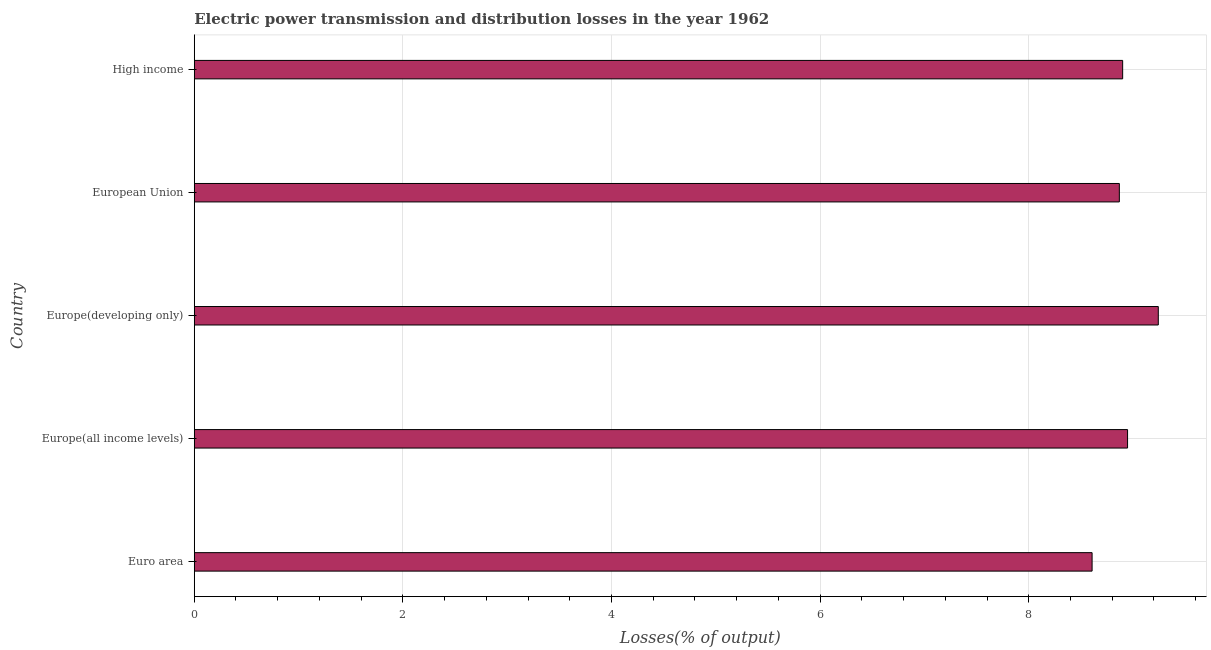Does the graph contain any zero values?
Keep it short and to the point. No. What is the title of the graph?
Offer a very short reply. Electric power transmission and distribution losses in the year 1962. What is the label or title of the X-axis?
Your answer should be very brief. Losses(% of output). What is the electric power transmission and distribution losses in High income?
Provide a succinct answer. 8.9. Across all countries, what is the maximum electric power transmission and distribution losses?
Your response must be concise. 9.24. Across all countries, what is the minimum electric power transmission and distribution losses?
Give a very brief answer. 8.61. In which country was the electric power transmission and distribution losses maximum?
Your response must be concise. Europe(developing only). In which country was the electric power transmission and distribution losses minimum?
Give a very brief answer. Euro area. What is the sum of the electric power transmission and distribution losses?
Give a very brief answer. 44.56. What is the difference between the electric power transmission and distribution losses in Euro area and Europe(developing only)?
Provide a succinct answer. -0.64. What is the average electric power transmission and distribution losses per country?
Keep it short and to the point. 8.91. What is the median electric power transmission and distribution losses?
Make the answer very short. 8.9. What is the ratio of the electric power transmission and distribution losses in Europe(developing only) to that in High income?
Provide a short and direct response. 1.04. What is the difference between the highest and the second highest electric power transmission and distribution losses?
Keep it short and to the point. 0.29. Is the sum of the electric power transmission and distribution losses in Europe(developing only) and European Union greater than the maximum electric power transmission and distribution losses across all countries?
Offer a terse response. Yes. What is the difference between the highest and the lowest electric power transmission and distribution losses?
Make the answer very short. 0.63. How many bars are there?
Keep it short and to the point. 5. Are all the bars in the graph horizontal?
Provide a short and direct response. Yes. What is the difference between two consecutive major ticks on the X-axis?
Your answer should be very brief. 2. Are the values on the major ticks of X-axis written in scientific E-notation?
Your answer should be compact. No. What is the Losses(% of output) of Euro area?
Your answer should be very brief. 8.61. What is the Losses(% of output) in Europe(all income levels)?
Provide a short and direct response. 8.95. What is the Losses(% of output) of Europe(developing only)?
Your answer should be compact. 9.24. What is the Losses(% of output) of European Union?
Give a very brief answer. 8.87. What is the Losses(% of output) in High income?
Your answer should be very brief. 8.9. What is the difference between the Losses(% of output) in Euro area and Europe(all income levels)?
Your answer should be very brief. -0.34. What is the difference between the Losses(% of output) in Euro area and Europe(developing only)?
Give a very brief answer. -0.63. What is the difference between the Losses(% of output) in Euro area and European Union?
Keep it short and to the point. -0.26. What is the difference between the Losses(% of output) in Euro area and High income?
Provide a short and direct response. -0.29. What is the difference between the Losses(% of output) in Europe(all income levels) and Europe(developing only)?
Provide a short and direct response. -0.29. What is the difference between the Losses(% of output) in Europe(all income levels) and European Union?
Make the answer very short. 0.08. What is the difference between the Losses(% of output) in Europe(all income levels) and High income?
Offer a terse response. 0.05. What is the difference between the Losses(% of output) in Europe(developing only) and European Union?
Your answer should be compact. 0.37. What is the difference between the Losses(% of output) in Europe(developing only) and High income?
Ensure brevity in your answer.  0.34. What is the difference between the Losses(% of output) in European Union and High income?
Ensure brevity in your answer.  -0.03. What is the ratio of the Losses(% of output) in Euro area to that in Europe(all income levels)?
Give a very brief answer. 0.96. What is the ratio of the Losses(% of output) in Euro area to that in Europe(developing only)?
Offer a very short reply. 0.93. What is the ratio of the Losses(% of output) in Europe(all income levels) to that in European Union?
Offer a terse response. 1.01. What is the ratio of the Losses(% of output) in Europe(developing only) to that in European Union?
Provide a short and direct response. 1.04. What is the ratio of the Losses(% of output) in Europe(developing only) to that in High income?
Keep it short and to the point. 1.04. What is the ratio of the Losses(% of output) in European Union to that in High income?
Offer a very short reply. 1. 